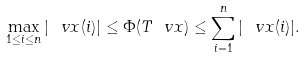<formula> <loc_0><loc_0><loc_500><loc_500>\max _ { 1 \leq i \leq n } | \ v x ( i ) | \leq \Phi ( T \ v x ) \leq \sum _ { i = 1 } ^ { n } | \ v x ( i ) | .</formula> 